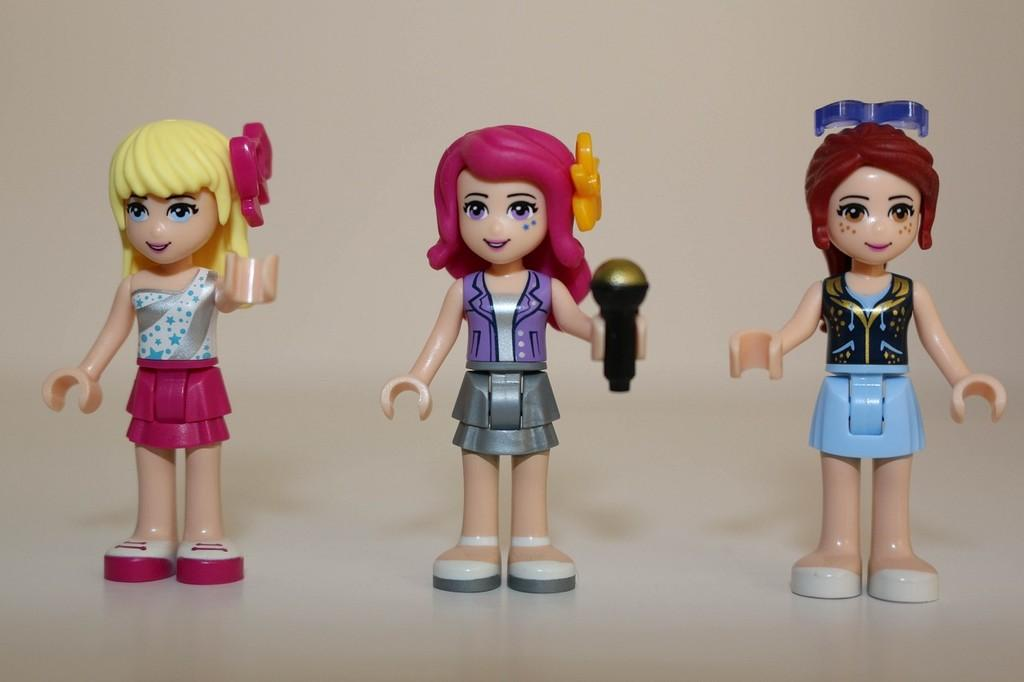What objects can be seen in the image? There are toys in the image. What can be observed about the setting in the image? The background of the image is plain. What company is responsible for creating the riddle that the son is trying to solve in the image? There is no company, riddle, or son present in the image. 